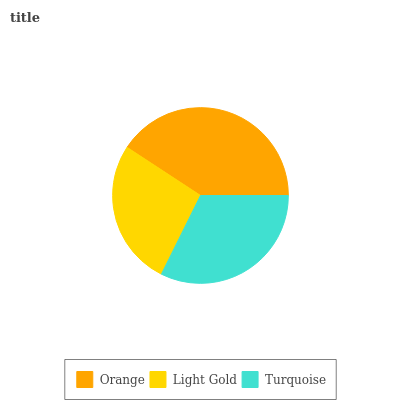Is Light Gold the minimum?
Answer yes or no. Yes. Is Orange the maximum?
Answer yes or no. Yes. Is Turquoise the minimum?
Answer yes or no. No. Is Turquoise the maximum?
Answer yes or no. No. Is Turquoise greater than Light Gold?
Answer yes or no. Yes. Is Light Gold less than Turquoise?
Answer yes or no. Yes. Is Light Gold greater than Turquoise?
Answer yes or no. No. Is Turquoise less than Light Gold?
Answer yes or no. No. Is Turquoise the high median?
Answer yes or no. Yes. Is Turquoise the low median?
Answer yes or no. Yes. Is Orange the high median?
Answer yes or no. No. Is Light Gold the low median?
Answer yes or no. No. 